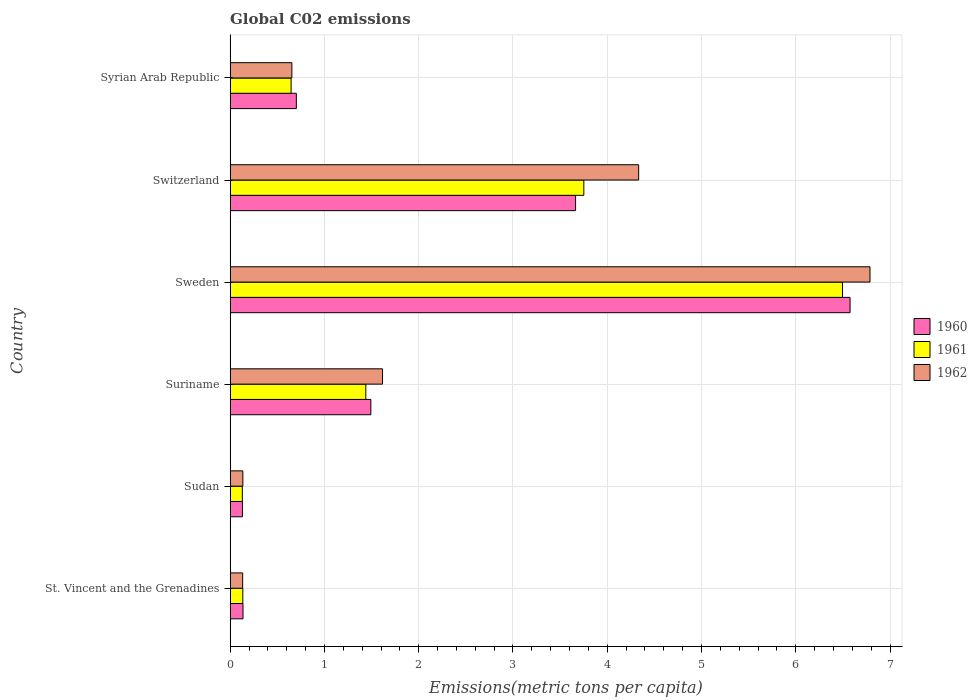How many different coloured bars are there?
Offer a very short reply. 3. How many groups of bars are there?
Give a very brief answer. 6. Are the number of bars per tick equal to the number of legend labels?
Ensure brevity in your answer.  Yes. Are the number of bars on each tick of the Y-axis equal?
Offer a terse response. Yes. How many bars are there on the 6th tick from the top?
Provide a short and direct response. 3. In how many cases, is the number of bars for a given country not equal to the number of legend labels?
Your answer should be compact. 0. What is the amount of CO2 emitted in in 1960 in Switzerland?
Provide a short and direct response. 3.66. Across all countries, what is the maximum amount of CO2 emitted in in 1960?
Your answer should be very brief. 6.58. Across all countries, what is the minimum amount of CO2 emitted in in 1961?
Make the answer very short. 0.13. In which country was the amount of CO2 emitted in in 1960 minimum?
Your answer should be compact. Sudan. What is the total amount of CO2 emitted in in 1962 in the graph?
Your answer should be compact. 13.66. What is the difference between the amount of CO2 emitted in in 1961 in Suriname and that in Sweden?
Your answer should be very brief. -5.06. What is the difference between the amount of CO2 emitted in in 1961 in Sudan and the amount of CO2 emitted in in 1960 in Syrian Arab Republic?
Keep it short and to the point. -0.57. What is the average amount of CO2 emitted in in 1961 per country?
Keep it short and to the point. 2.1. What is the difference between the amount of CO2 emitted in in 1962 and amount of CO2 emitted in in 1961 in Syrian Arab Republic?
Your answer should be very brief. 0.01. What is the ratio of the amount of CO2 emitted in in 1961 in Suriname to that in Sweden?
Your answer should be compact. 0.22. Is the difference between the amount of CO2 emitted in in 1962 in St. Vincent and the Grenadines and Sweden greater than the difference between the amount of CO2 emitted in in 1961 in St. Vincent and the Grenadines and Sweden?
Offer a very short reply. No. What is the difference between the highest and the second highest amount of CO2 emitted in in 1960?
Offer a terse response. 2.91. What is the difference between the highest and the lowest amount of CO2 emitted in in 1960?
Ensure brevity in your answer.  6.45. Is the sum of the amount of CO2 emitted in in 1960 in St. Vincent and the Grenadines and Sweden greater than the maximum amount of CO2 emitted in in 1961 across all countries?
Give a very brief answer. Yes. What does the 2nd bar from the bottom in Syrian Arab Republic represents?
Ensure brevity in your answer.  1961. Is it the case that in every country, the sum of the amount of CO2 emitted in in 1960 and amount of CO2 emitted in in 1961 is greater than the amount of CO2 emitted in in 1962?
Ensure brevity in your answer.  Yes. How many bars are there?
Provide a short and direct response. 18. Are all the bars in the graph horizontal?
Your response must be concise. Yes. How many countries are there in the graph?
Offer a very short reply. 6. What is the difference between two consecutive major ticks on the X-axis?
Give a very brief answer. 1. Are the values on the major ticks of X-axis written in scientific E-notation?
Your answer should be very brief. No. Does the graph contain any zero values?
Offer a terse response. No. How are the legend labels stacked?
Offer a very short reply. Vertical. What is the title of the graph?
Give a very brief answer. Global C02 emissions. Does "1995" appear as one of the legend labels in the graph?
Your answer should be compact. No. What is the label or title of the X-axis?
Keep it short and to the point. Emissions(metric tons per capita). What is the label or title of the Y-axis?
Provide a short and direct response. Country. What is the Emissions(metric tons per capita) in 1960 in St. Vincent and the Grenadines?
Provide a short and direct response. 0.14. What is the Emissions(metric tons per capita) of 1961 in St. Vincent and the Grenadines?
Your response must be concise. 0.13. What is the Emissions(metric tons per capita) in 1962 in St. Vincent and the Grenadines?
Provide a short and direct response. 0.13. What is the Emissions(metric tons per capita) of 1960 in Sudan?
Provide a short and direct response. 0.13. What is the Emissions(metric tons per capita) in 1961 in Sudan?
Make the answer very short. 0.13. What is the Emissions(metric tons per capita) in 1962 in Sudan?
Ensure brevity in your answer.  0.13. What is the Emissions(metric tons per capita) in 1960 in Suriname?
Your answer should be compact. 1.49. What is the Emissions(metric tons per capita) in 1961 in Suriname?
Provide a short and direct response. 1.44. What is the Emissions(metric tons per capita) in 1962 in Suriname?
Make the answer very short. 1.62. What is the Emissions(metric tons per capita) in 1960 in Sweden?
Your answer should be very brief. 6.58. What is the Emissions(metric tons per capita) of 1961 in Sweden?
Your answer should be very brief. 6.5. What is the Emissions(metric tons per capita) in 1962 in Sweden?
Offer a very short reply. 6.79. What is the Emissions(metric tons per capita) in 1960 in Switzerland?
Your answer should be very brief. 3.66. What is the Emissions(metric tons per capita) of 1961 in Switzerland?
Provide a succinct answer. 3.75. What is the Emissions(metric tons per capita) in 1962 in Switzerland?
Provide a succinct answer. 4.33. What is the Emissions(metric tons per capita) in 1960 in Syrian Arab Republic?
Ensure brevity in your answer.  0.7. What is the Emissions(metric tons per capita) in 1961 in Syrian Arab Republic?
Give a very brief answer. 0.65. What is the Emissions(metric tons per capita) of 1962 in Syrian Arab Republic?
Make the answer very short. 0.65. Across all countries, what is the maximum Emissions(metric tons per capita) in 1960?
Ensure brevity in your answer.  6.58. Across all countries, what is the maximum Emissions(metric tons per capita) of 1961?
Your response must be concise. 6.5. Across all countries, what is the maximum Emissions(metric tons per capita) in 1962?
Ensure brevity in your answer.  6.79. Across all countries, what is the minimum Emissions(metric tons per capita) in 1960?
Your answer should be compact. 0.13. Across all countries, what is the minimum Emissions(metric tons per capita) in 1961?
Your answer should be very brief. 0.13. Across all countries, what is the minimum Emissions(metric tons per capita) of 1962?
Make the answer very short. 0.13. What is the total Emissions(metric tons per capita) of 1960 in the graph?
Your answer should be very brief. 12.7. What is the total Emissions(metric tons per capita) of 1961 in the graph?
Your response must be concise. 12.6. What is the total Emissions(metric tons per capita) of 1962 in the graph?
Provide a succinct answer. 13.66. What is the difference between the Emissions(metric tons per capita) in 1960 in St. Vincent and the Grenadines and that in Sudan?
Give a very brief answer. 0.01. What is the difference between the Emissions(metric tons per capita) of 1961 in St. Vincent and the Grenadines and that in Sudan?
Provide a short and direct response. 0.01. What is the difference between the Emissions(metric tons per capita) of 1962 in St. Vincent and the Grenadines and that in Sudan?
Provide a short and direct response. -0. What is the difference between the Emissions(metric tons per capita) of 1960 in St. Vincent and the Grenadines and that in Suriname?
Make the answer very short. -1.36. What is the difference between the Emissions(metric tons per capita) of 1961 in St. Vincent and the Grenadines and that in Suriname?
Give a very brief answer. -1.3. What is the difference between the Emissions(metric tons per capita) in 1962 in St. Vincent and the Grenadines and that in Suriname?
Make the answer very short. -1.48. What is the difference between the Emissions(metric tons per capita) of 1960 in St. Vincent and the Grenadines and that in Sweden?
Offer a terse response. -6.44. What is the difference between the Emissions(metric tons per capita) of 1961 in St. Vincent and the Grenadines and that in Sweden?
Your answer should be compact. -6.36. What is the difference between the Emissions(metric tons per capita) of 1962 in St. Vincent and the Grenadines and that in Sweden?
Offer a terse response. -6.66. What is the difference between the Emissions(metric tons per capita) in 1960 in St. Vincent and the Grenadines and that in Switzerland?
Offer a very short reply. -3.53. What is the difference between the Emissions(metric tons per capita) in 1961 in St. Vincent and the Grenadines and that in Switzerland?
Keep it short and to the point. -3.62. What is the difference between the Emissions(metric tons per capita) of 1962 in St. Vincent and the Grenadines and that in Switzerland?
Provide a short and direct response. -4.2. What is the difference between the Emissions(metric tons per capita) in 1960 in St. Vincent and the Grenadines and that in Syrian Arab Republic?
Offer a very short reply. -0.57. What is the difference between the Emissions(metric tons per capita) of 1961 in St. Vincent and the Grenadines and that in Syrian Arab Republic?
Keep it short and to the point. -0.51. What is the difference between the Emissions(metric tons per capita) in 1962 in St. Vincent and the Grenadines and that in Syrian Arab Republic?
Give a very brief answer. -0.52. What is the difference between the Emissions(metric tons per capita) in 1960 in Sudan and that in Suriname?
Your answer should be very brief. -1.36. What is the difference between the Emissions(metric tons per capita) of 1961 in Sudan and that in Suriname?
Offer a terse response. -1.31. What is the difference between the Emissions(metric tons per capita) of 1962 in Sudan and that in Suriname?
Provide a short and direct response. -1.48. What is the difference between the Emissions(metric tons per capita) of 1960 in Sudan and that in Sweden?
Your response must be concise. -6.45. What is the difference between the Emissions(metric tons per capita) of 1961 in Sudan and that in Sweden?
Ensure brevity in your answer.  -6.37. What is the difference between the Emissions(metric tons per capita) in 1962 in Sudan and that in Sweden?
Your response must be concise. -6.65. What is the difference between the Emissions(metric tons per capita) in 1960 in Sudan and that in Switzerland?
Offer a terse response. -3.53. What is the difference between the Emissions(metric tons per capita) of 1961 in Sudan and that in Switzerland?
Provide a short and direct response. -3.62. What is the difference between the Emissions(metric tons per capita) in 1962 in Sudan and that in Switzerland?
Your answer should be very brief. -4.2. What is the difference between the Emissions(metric tons per capita) in 1960 in Sudan and that in Syrian Arab Republic?
Offer a very short reply. -0.57. What is the difference between the Emissions(metric tons per capita) in 1961 in Sudan and that in Syrian Arab Republic?
Offer a terse response. -0.52. What is the difference between the Emissions(metric tons per capita) in 1962 in Sudan and that in Syrian Arab Republic?
Offer a very short reply. -0.52. What is the difference between the Emissions(metric tons per capita) of 1960 in Suriname and that in Sweden?
Your answer should be compact. -5.08. What is the difference between the Emissions(metric tons per capita) of 1961 in Suriname and that in Sweden?
Ensure brevity in your answer.  -5.06. What is the difference between the Emissions(metric tons per capita) in 1962 in Suriname and that in Sweden?
Make the answer very short. -5.17. What is the difference between the Emissions(metric tons per capita) of 1960 in Suriname and that in Switzerland?
Keep it short and to the point. -2.17. What is the difference between the Emissions(metric tons per capita) of 1961 in Suriname and that in Switzerland?
Give a very brief answer. -2.31. What is the difference between the Emissions(metric tons per capita) in 1962 in Suriname and that in Switzerland?
Keep it short and to the point. -2.72. What is the difference between the Emissions(metric tons per capita) in 1960 in Suriname and that in Syrian Arab Republic?
Give a very brief answer. 0.79. What is the difference between the Emissions(metric tons per capita) in 1961 in Suriname and that in Syrian Arab Republic?
Keep it short and to the point. 0.79. What is the difference between the Emissions(metric tons per capita) of 1962 in Suriname and that in Syrian Arab Republic?
Your answer should be very brief. 0.96. What is the difference between the Emissions(metric tons per capita) of 1960 in Sweden and that in Switzerland?
Offer a terse response. 2.91. What is the difference between the Emissions(metric tons per capita) of 1961 in Sweden and that in Switzerland?
Your response must be concise. 2.74. What is the difference between the Emissions(metric tons per capita) in 1962 in Sweden and that in Switzerland?
Ensure brevity in your answer.  2.45. What is the difference between the Emissions(metric tons per capita) in 1960 in Sweden and that in Syrian Arab Republic?
Your answer should be compact. 5.87. What is the difference between the Emissions(metric tons per capita) in 1961 in Sweden and that in Syrian Arab Republic?
Your response must be concise. 5.85. What is the difference between the Emissions(metric tons per capita) of 1962 in Sweden and that in Syrian Arab Republic?
Your response must be concise. 6.13. What is the difference between the Emissions(metric tons per capita) in 1960 in Switzerland and that in Syrian Arab Republic?
Make the answer very short. 2.96. What is the difference between the Emissions(metric tons per capita) of 1961 in Switzerland and that in Syrian Arab Republic?
Your answer should be very brief. 3.11. What is the difference between the Emissions(metric tons per capita) in 1962 in Switzerland and that in Syrian Arab Republic?
Provide a short and direct response. 3.68. What is the difference between the Emissions(metric tons per capita) of 1960 in St. Vincent and the Grenadines and the Emissions(metric tons per capita) of 1961 in Sudan?
Ensure brevity in your answer.  0.01. What is the difference between the Emissions(metric tons per capita) in 1960 in St. Vincent and the Grenadines and the Emissions(metric tons per capita) in 1962 in Sudan?
Your answer should be very brief. 0. What is the difference between the Emissions(metric tons per capita) in 1961 in St. Vincent and the Grenadines and the Emissions(metric tons per capita) in 1962 in Sudan?
Provide a succinct answer. -0. What is the difference between the Emissions(metric tons per capita) in 1960 in St. Vincent and the Grenadines and the Emissions(metric tons per capita) in 1961 in Suriname?
Keep it short and to the point. -1.3. What is the difference between the Emissions(metric tons per capita) of 1960 in St. Vincent and the Grenadines and the Emissions(metric tons per capita) of 1962 in Suriname?
Make the answer very short. -1.48. What is the difference between the Emissions(metric tons per capita) of 1961 in St. Vincent and the Grenadines and the Emissions(metric tons per capita) of 1962 in Suriname?
Your response must be concise. -1.48. What is the difference between the Emissions(metric tons per capita) of 1960 in St. Vincent and the Grenadines and the Emissions(metric tons per capita) of 1961 in Sweden?
Ensure brevity in your answer.  -6.36. What is the difference between the Emissions(metric tons per capita) of 1960 in St. Vincent and the Grenadines and the Emissions(metric tons per capita) of 1962 in Sweden?
Your answer should be compact. -6.65. What is the difference between the Emissions(metric tons per capita) in 1961 in St. Vincent and the Grenadines and the Emissions(metric tons per capita) in 1962 in Sweden?
Provide a succinct answer. -6.65. What is the difference between the Emissions(metric tons per capita) in 1960 in St. Vincent and the Grenadines and the Emissions(metric tons per capita) in 1961 in Switzerland?
Offer a very short reply. -3.62. What is the difference between the Emissions(metric tons per capita) of 1960 in St. Vincent and the Grenadines and the Emissions(metric tons per capita) of 1962 in Switzerland?
Your answer should be compact. -4.2. What is the difference between the Emissions(metric tons per capita) in 1961 in St. Vincent and the Grenadines and the Emissions(metric tons per capita) in 1962 in Switzerland?
Ensure brevity in your answer.  -4.2. What is the difference between the Emissions(metric tons per capita) in 1960 in St. Vincent and the Grenadines and the Emissions(metric tons per capita) in 1961 in Syrian Arab Republic?
Offer a very short reply. -0.51. What is the difference between the Emissions(metric tons per capita) of 1960 in St. Vincent and the Grenadines and the Emissions(metric tons per capita) of 1962 in Syrian Arab Republic?
Your answer should be compact. -0.52. What is the difference between the Emissions(metric tons per capita) of 1961 in St. Vincent and the Grenadines and the Emissions(metric tons per capita) of 1962 in Syrian Arab Republic?
Give a very brief answer. -0.52. What is the difference between the Emissions(metric tons per capita) of 1960 in Sudan and the Emissions(metric tons per capita) of 1961 in Suriname?
Your response must be concise. -1.31. What is the difference between the Emissions(metric tons per capita) of 1960 in Sudan and the Emissions(metric tons per capita) of 1962 in Suriname?
Provide a succinct answer. -1.49. What is the difference between the Emissions(metric tons per capita) of 1961 in Sudan and the Emissions(metric tons per capita) of 1962 in Suriname?
Your answer should be very brief. -1.49. What is the difference between the Emissions(metric tons per capita) in 1960 in Sudan and the Emissions(metric tons per capita) in 1961 in Sweden?
Make the answer very short. -6.37. What is the difference between the Emissions(metric tons per capita) of 1960 in Sudan and the Emissions(metric tons per capita) of 1962 in Sweden?
Offer a terse response. -6.66. What is the difference between the Emissions(metric tons per capita) of 1961 in Sudan and the Emissions(metric tons per capita) of 1962 in Sweden?
Ensure brevity in your answer.  -6.66. What is the difference between the Emissions(metric tons per capita) of 1960 in Sudan and the Emissions(metric tons per capita) of 1961 in Switzerland?
Offer a terse response. -3.62. What is the difference between the Emissions(metric tons per capita) of 1960 in Sudan and the Emissions(metric tons per capita) of 1962 in Switzerland?
Your answer should be compact. -4.2. What is the difference between the Emissions(metric tons per capita) of 1961 in Sudan and the Emissions(metric tons per capita) of 1962 in Switzerland?
Offer a terse response. -4.2. What is the difference between the Emissions(metric tons per capita) of 1960 in Sudan and the Emissions(metric tons per capita) of 1961 in Syrian Arab Republic?
Provide a succinct answer. -0.52. What is the difference between the Emissions(metric tons per capita) of 1960 in Sudan and the Emissions(metric tons per capita) of 1962 in Syrian Arab Republic?
Your response must be concise. -0.52. What is the difference between the Emissions(metric tons per capita) of 1961 in Sudan and the Emissions(metric tons per capita) of 1962 in Syrian Arab Republic?
Your response must be concise. -0.53. What is the difference between the Emissions(metric tons per capita) of 1960 in Suriname and the Emissions(metric tons per capita) of 1961 in Sweden?
Offer a terse response. -5. What is the difference between the Emissions(metric tons per capita) in 1960 in Suriname and the Emissions(metric tons per capita) in 1962 in Sweden?
Your answer should be very brief. -5.3. What is the difference between the Emissions(metric tons per capita) in 1961 in Suriname and the Emissions(metric tons per capita) in 1962 in Sweden?
Make the answer very short. -5.35. What is the difference between the Emissions(metric tons per capita) in 1960 in Suriname and the Emissions(metric tons per capita) in 1961 in Switzerland?
Keep it short and to the point. -2.26. What is the difference between the Emissions(metric tons per capita) of 1960 in Suriname and the Emissions(metric tons per capita) of 1962 in Switzerland?
Your response must be concise. -2.84. What is the difference between the Emissions(metric tons per capita) of 1961 in Suriname and the Emissions(metric tons per capita) of 1962 in Switzerland?
Your response must be concise. -2.89. What is the difference between the Emissions(metric tons per capita) of 1960 in Suriname and the Emissions(metric tons per capita) of 1961 in Syrian Arab Republic?
Your answer should be very brief. 0.85. What is the difference between the Emissions(metric tons per capita) in 1960 in Suriname and the Emissions(metric tons per capita) in 1962 in Syrian Arab Republic?
Make the answer very short. 0.84. What is the difference between the Emissions(metric tons per capita) of 1961 in Suriname and the Emissions(metric tons per capita) of 1962 in Syrian Arab Republic?
Give a very brief answer. 0.78. What is the difference between the Emissions(metric tons per capita) of 1960 in Sweden and the Emissions(metric tons per capita) of 1961 in Switzerland?
Keep it short and to the point. 2.82. What is the difference between the Emissions(metric tons per capita) of 1960 in Sweden and the Emissions(metric tons per capita) of 1962 in Switzerland?
Offer a very short reply. 2.24. What is the difference between the Emissions(metric tons per capita) of 1961 in Sweden and the Emissions(metric tons per capita) of 1962 in Switzerland?
Provide a short and direct response. 2.16. What is the difference between the Emissions(metric tons per capita) of 1960 in Sweden and the Emissions(metric tons per capita) of 1961 in Syrian Arab Republic?
Make the answer very short. 5.93. What is the difference between the Emissions(metric tons per capita) of 1960 in Sweden and the Emissions(metric tons per capita) of 1962 in Syrian Arab Republic?
Give a very brief answer. 5.92. What is the difference between the Emissions(metric tons per capita) of 1961 in Sweden and the Emissions(metric tons per capita) of 1962 in Syrian Arab Republic?
Offer a terse response. 5.84. What is the difference between the Emissions(metric tons per capita) in 1960 in Switzerland and the Emissions(metric tons per capita) in 1961 in Syrian Arab Republic?
Provide a short and direct response. 3.02. What is the difference between the Emissions(metric tons per capita) in 1960 in Switzerland and the Emissions(metric tons per capita) in 1962 in Syrian Arab Republic?
Your answer should be very brief. 3.01. What is the difference between the Emissions(metric tons per capita) of 1961 in Switzerland and the Emissions(metric tons per capita) of 1962 in Syrian Arab Republic?
Make the answer very short. 3.1. What is the average Emissions(metric tons per capita) in 1960 per country?
Keep it short and to the point. 2.12. What is the average Emissions(metric tons per capita) in 1961 per country?
Offer a very short reply. 2.1. What is the average Emissions(metric tons per capita) in 1962 per country?
Your answer should be very brief. 2.28. What is the difference between the Emissions(metric tons per capita) of 1960 and Emissions(metric tons per capita) of 1961 in St. Vincent and the Grenadines?
Ensure brevity in your answer.  0. What is the difference between the Emissions(metric tons per capita) in 1960 and Emissions(metric tons per capita) in 1962 in St. Vincent and the Grenadines?
Your answer should be compact. 0. What is the difference between the Emissions(metric tons per capita) in 1961 and Emissions(metric tons per capita) in 1962 in St. Vincent and the Grenadines?
Your answer should be very brief. 0. What is the difference between the Emissions(metric tons per capita) of 1960 and Emissions(metric tons per capita) of 1961 in Sudan?
Make the answer very short. 0. What is the difference between the Emissions(metric tons per capita) of 1960 and Emissions(metric tons per capita) of 1962 in Sudan?
Your answer should be compact. -0. What is the difference between the Emissions(metric tons per capita) of 1961 and Emissions(metric tons per capita) of 1962 in Sudan?
Provide a short and direct response. -0.01. What is the difference between the Emissions(metric tons per capita) in 1960 and Emissions(metric tons per capita) in 1961 in Suriname?
Keep it short and to the point. 0.05. What is the difference between the Emissions(metric tons per capita) of 1960 and Emissions(metric tons per capita) of 1962 in Suriname?
Offer a very short reply. -0.12. What is the difference between the Emissions(metric tons per capita) of 1961 and Emissions(metric tons per capita) of 1962 in Suriname?
Offer a very short reply. -0.18. What is the difference between the Emissions(metric tons per capita) in 1960 and Emissions(metric tons per capita) in 1961 in Sweden?
Make the answer very short. 0.08. What is the difference between the Emissions(metric tons per capita) of 1960 and Emissions(metric tons per capita) of 1962 in Sweden?
Keep it short and to the point. -0.21. What is the difference between the Emissions(metric tons per capita) in 1961 and Emissions(metric tons per capita) in 1962 in Sweden?
Offer a very short reply. -0.29. What is the difference between the Emissions(metric tons per capita) of 1960 and Emissions(metric tons per capita) of 1961 in Switzerland?
Your response must be concise. -0.09. What is the difference between the Emissions(metric tons per capita) in 1960 and Emissions(metric tons per capita) in 1962 in Switzerland?
Make the answer very short. -0.67. What is the difference between the Emissions(metric tons per capita) in 1961 and Emissions(metric tons per capita) in 1962 in Switzerland?
Your answer should be very brief. -0.58. What is the difference between the Emissions(metric tons per capita) in 1960 and Emissions(metric tons per capita) in 1961 in Syrian Arab Republic?
Make the answer very short. 0.06. What is the difference between the Emissions(metric tons per capita) in 1960 and Emissions(metric tons per capita) in 1962 in Syrian Arab Republic?
Offer a very short reply. 0.05. What is the difference between the Emissions(metric tons per capita) in 1961 and Emissions(metric tons per capita) in 1962 in Syrian Arab Republic?
Provide a succinct answer. -0.01. What is the ratio of the Emissions(metric tons per capita) of 1960 in St. Vincent and the Grenadines to that in Sudan?
Keep it short and to the point. 1.05. What is the ratio of the Emissions(metric tons per capita) of 1961 in St. Vincent and the Grenadines to that in Sudan?
Your answer should be very brief. 1.04. What is the ratio of the Emissions(metric tons per capita) of 1962 in St. Vincent and the Grenadines to that in Sudan?
Your response must be concise. 0.98. What is the ratio of the Emissions(metric tons per capita) of 1960 in St. Vincent and the Grenadines to that in Suriname?
Your answer should be very brief. 0.09. What is the ratio of the Emissions(metric tons per capita) of 1961 in St. Vincent and the Grenadines to that in Suriname?
Give a very brief answer. 0.09. What is the ratio of the Emissions(metric tons per capita) of 1962 in St. Vincent and the Grenadines to that in Suriname?
Your answer should be very brief. 0.08. What is the ratio of the Emissions(metric tons per capita) of 1960 in St. Vincent and the Grenadines to that in Sweden?
Your answer should be very brief. 0.02. What is the ratio of the Emissions(metric tons per capita) in 1961 in St. Vincent and the Grenadines to that in Sweden?
Offer a very short reply. 0.02. What is the ratio of the Emissions(metric tons per capita) of 1962 in St. Vincent and the Grenadines to that in Sweden?
Your answer should be compact. 0.02. What is the ratio of the Emissions(metric tons per capita) of 1960 in St. Vincent and the Grenadines to that in Switzerland?
Ensure brevity in your answer.  0.04. What is the ratio of the Emissions(metric tons per capita) in 1961 in St. Vincent and the Grenadines to that in Switzerland?
Offer a very short reply. 0.04. What is the ratio of the Emissions(metric tons per capita) in 1962 in St. Vincent and the Grenadines to that in Switzerland?
Offer a terse response. 0.03. What is the ratio of the Emissions(metric tons per capita) of 1960 in St. Vincent and the Grenadines to that in Syrian Arab Republic?
Offer a very short reply. 0.19. What is the ratio of the Emissions(metric tons per capita) in 1961 in St. Vincent and the Grenadines to that in Syrian Arab Republic?
Make the answer very short. 0.21. What is the ratio of the Emissions(metric tons per capita) in 1962 in St. Vincent and the Grenadines to that in Syrian Arab Republic?
Offer a terse response. 0.2. What is the ratio of the Emissions(metric tons per capita) in 1960 in Sudan to that in Suriname?
Your response must be concise. 0.09. What is the ratio of the Emissions(metric tons per capita) of 1961 in Sudan to that in Suriname?
Your response must be concise. 0.09. What is the ratio of the Emissions(metric tons per capita) in 1962 in Sudan to that in Suriname?
Offer a terse response. 0.08. What is the ratio of the Emissions(metric tons per capita) in 1960 in Sudan to that in Sweden?
Keep it short and to the point. 0.02. What is the ratio of the Emissions(metric tons per capita) in 1961 in Sudan to that in Sweden?
Ensure brevity in your answer.  0.02. What is the ratio of the Emissions(metric tons per capita) of 1962 in Sudan to that in Sweden?
Provide a succinct answer. 0.02. What is the ratio of the Emissions(metric tons per capita) of 1960 in Sudan to that in Switzerland?
Your answer should be very brief. 0.04. What is the ratio of the Emissions(metric tons per capita) of 1961 in Sudan to that in Switzerland?
Keep it short and to the point. 0.03. What is the ratio of the Emissions(metric tons per capita) of 1962 in Sudan to that in Switzerland?
Your answer should be very brief. 0.03. What is the ratio of the Emissions(metric tons per capita) in 1960 in Sudan to that in Syrian Arab Republic?
Give a very brief answer. 0.18. What is the ratio of the Emissions(metric tons per capita) of 1961 in Sudan to that in Syrian Arab Republic?
Make the answer very short. 0.2. What is the ratio of the Emissions(metric tons per capita) of 1962 in Sudan to that in Syrian Arab Republic?
Keep it short and to the point. 0.21. What is the ratio of the Emissions(metric tons per capita) of 1960 in Suriname to that in Sweden?
Provide a succinct answer. 0.23. What is the ratio of the Emissions(metric tons per capita) of 1961 in Suriname to that in Sweden?
Your answer should be compact. 0.22. What is the ratio of the Emissions(metric tons per capita) of 1962 in Suriname to that in Sweden?
Make the answer very short. 0.24. What is the ratio of the Emissions(metric tons per capita) of 1960 in Suriname to that in Switzerland?
Provide a succinct answer. 0.41. What is the ratio of the Emissions(metric tons per capita) of 1961 in Suriname to that in Switzerland?
Keep it short and to the point. 0.38. What is the ratio of the Emissions(metric tons per capita) in 1962 in Suriname to that in Switzerland?
Give a very brief answer. 0.37. What is the ratio of the Emissions(metric tons per capita) of 1960 in Suriname to that in Syrian Arab Republic?
Make the answer very short. 2.13. What is the ratio of the Emissions(metric tons per capita) in 1961 in Suriname to that in Syrian Arab Republic?
Keep it short and to the point. 2.23. What is the ratio of the Emissions(metric tons per capita) in 1962 in Suriname to that in Syrian Arab Republic?
Offer a very short reply. 2.47. What is the ratio of the Emissions(metric tons per capita) of 1960 in Sweden to that in Switzerland?
Provide a short and direct response. 1.79. What is the ratio of the Emissions(metric tons per capita) in 1961 in Sweden to that in Switzerland?
Offer a very short reply. 1.73. What is the ratio of the Emissions(metric tons per capita) in 1962 in Sweden to that in Switzerland?
Your answer should be compact. 1.57. What is the ratio of the Emissions(metric tons per capita) of 1960 in Sweden to that in Syrian Arab Republic?
Ensure brevity in your answer.  9.37. What is the ratio of the Emissions(metric tons per capita) of 1961 in Sweden to that in Syrian Arab Republic?
Your answer should be compact. 10.05. What is the ratio of the Emissions(metric tons per capita) of 1962 in Sweden to that in Syrian Arab Republic?
Offer a very short reply. 10.37. What is the ratio of the Emissions(metric tons per capita) of 1960 in Switzerland to that in Syrian Arab Republic?
Give a very brief answer. 5.22. What is the ratio of the Emissions(metric tons per capita) of 1961 in Switzerland to that in Syrian Arab Republic?
Provide a short and direct response. 5.8. What is the ratio of the Emissions(metric tons per capita) of 1962 in Switzerland to that in Syrian Arab Republic?
Give a very brief answer. 6.62. What is the difference between the highest and the second highest Emissions(metric tons per capita) in 1960?
Ensure brevity in your answer.  2.91. What is the difference between the highest and the second highest Emissions(metric tons per capita) of 1961?
Provide a short and direct response. 2.74. What is the difference between the highest and the second highest Emissions(metric tons per capita) of 1962?
Offer a terse response. 2.45. What is the difference between the highest and the lowest Emissions(metric tons per capita) in 1960?
Your answer should be compact. 6.45. What is the difference between the highest and the lowest Emissions(metric tons per capita) of 1961?
Provide a succinct answer. 6.37. What is the difference between the highest and the lowest Emissions(metric tons per capita) in 1962?
Give a very brief answer. 6.66. 